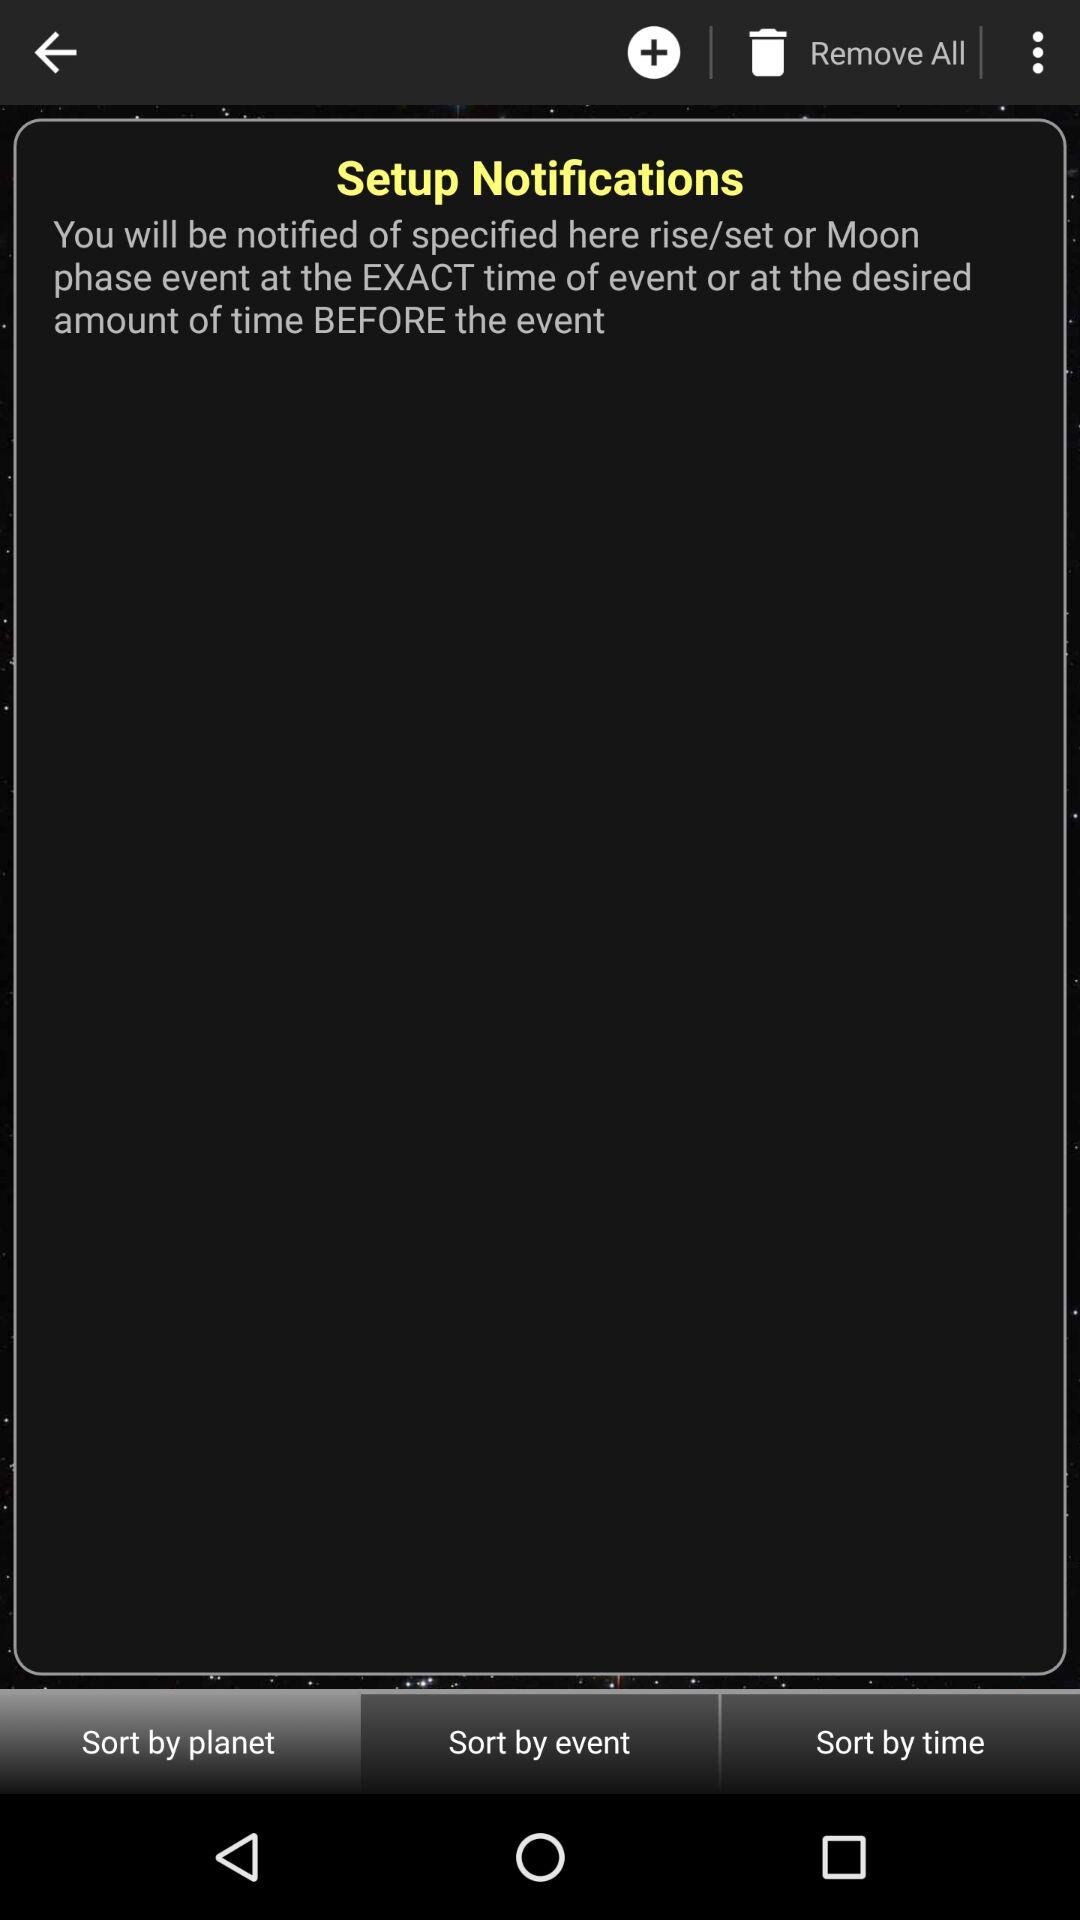Which tab is selected? The tab "Sort by planet" is selected. 